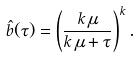<formula> <loc_0><loc_0><loc_500><loc_500>\hat { b } ( \tau ) = \left ( \frac { k \, \mu } { k \, \mu + \tau } \right ) ^ { k } .</formula> 